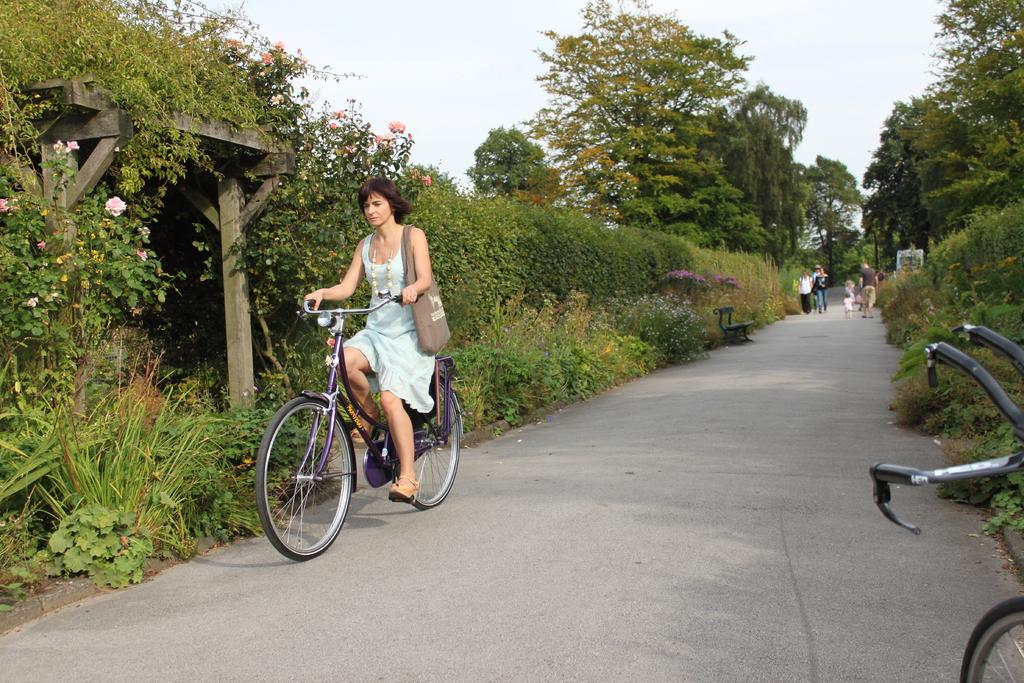Who is the main subject in the image? There is a woman in the image. What is the woman doing in the image? The woman is riding a bicycle. Where is the bicycle located? The bicycle is on the road. What can be seen in the background of the image? There are plants, trees, and the sky visible in the background of the image. What type of dog is sitting next to the woman on the bicycle? There is no dog present in the image; the woman is riding the bicycle alone. 